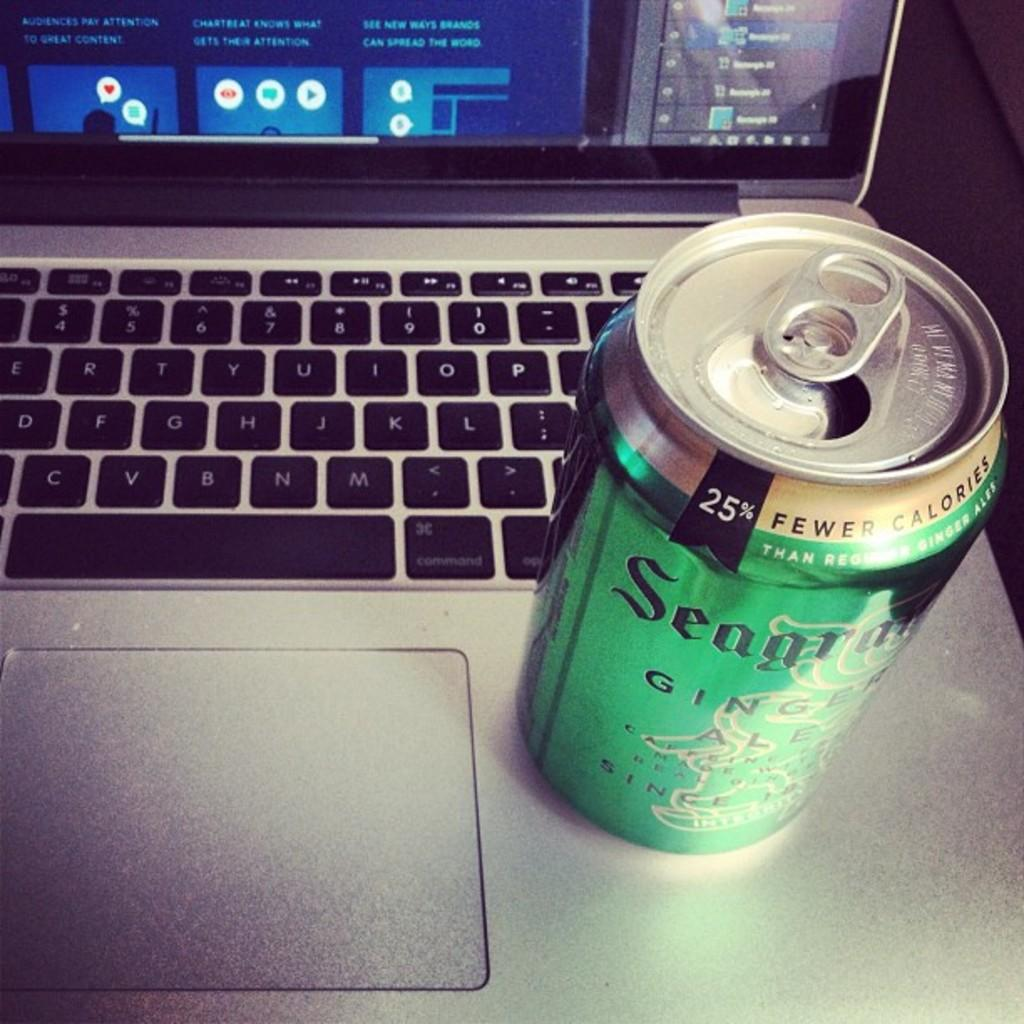<image>
Offer a succinct explanation of the picture presented. A can of Seagram's ginger ale on the corner of a laptop. 